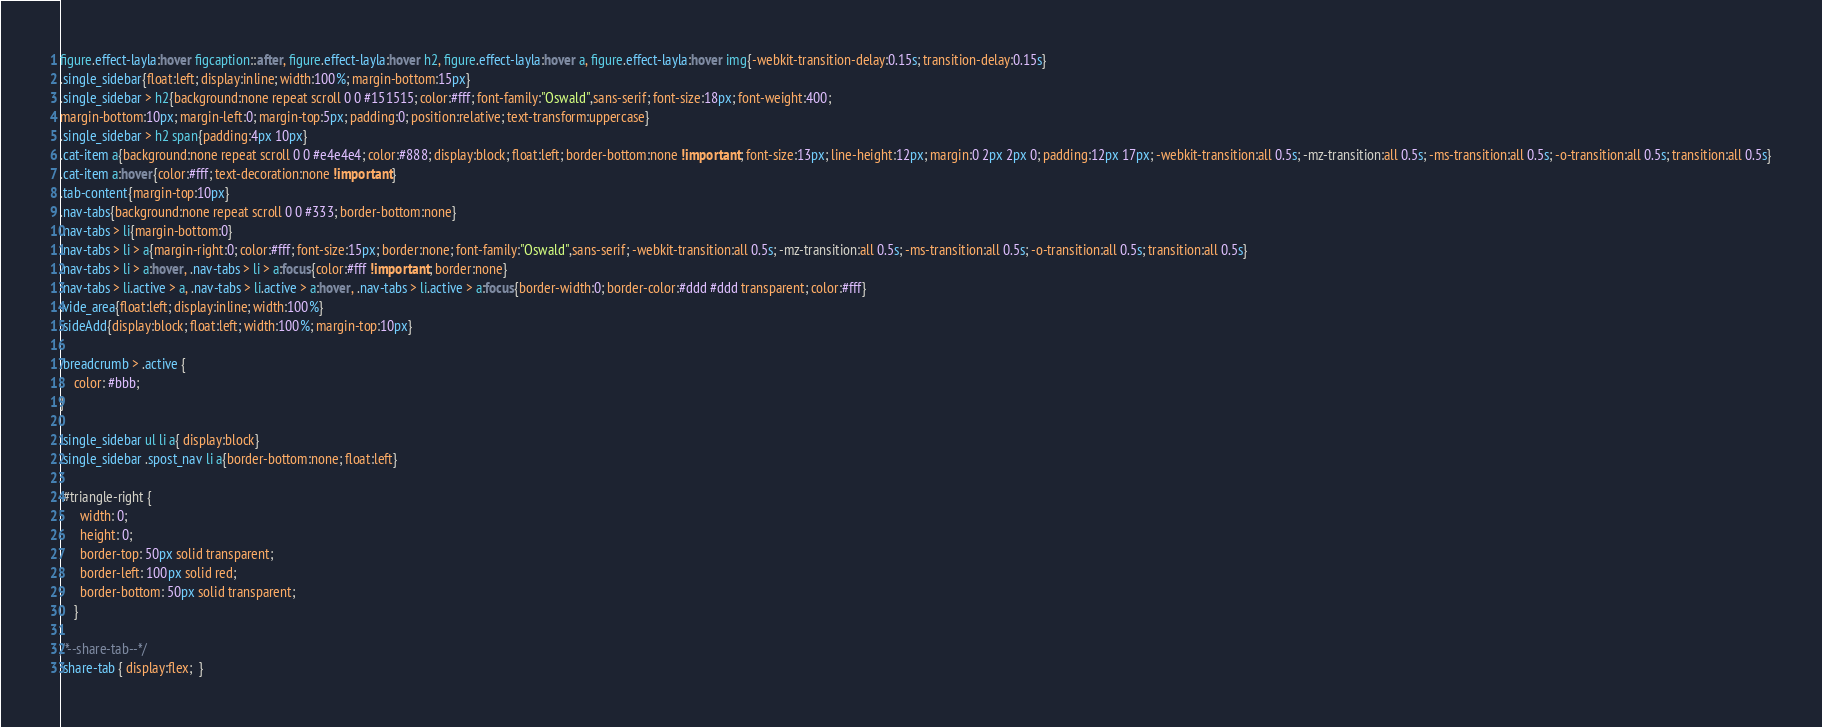Convert code to text. <code><loc_0><loc_0><loc_500><loc_500><_CSS_>figure.effect-layla:hover figcaption::after, figure.effect-layla:hover h2, figure.effect-layla:hover a, figure.effect-layla:hover img{-webkit-transition-delay:0.15s; transition-delay:0.15s}
.single_sidebar{float:left; display:inline; width:100%; margin-bottom:15px}
.single_sidebar > h2{background:none repeat scroll 0 0 #151515; color:#fff; font-family:"Oswald",sans-serif; font-size:18px; font-weight:400; 
margin-bottom:10px; margin-left:0; margin-top:5px; padding:0; position:relative; text-transform:uppercase}
.single_sidebar > h2 span{padding:4px 10px}
.cat-item a{background:none repeat scroll 0 0 #e4e4e4; color:#888; display:block; float:left; border-bottom:none !important; font-size:13px; line-height:12px; margin:0 2px 2px 0; padding:12px 17px; -webkit-transition:all 0.5s; -mz-transition:all 0.5s; -ms-transition:all 0.5s; -o-transition:all 0.5s; transition:all 0.5s}
.cat-item a:hover{color:#fff; text-decoration:none !important}
.tab-content{margin-top:10px}
.nav-tabs{background:none repeat scroll 0 0 #333; border-bottom:none}
.nav-tabs > li{margin-bottom:0}
.nav-tabs > li > a{margin-right:0; color:#fff; font-size:15px; border:none; font-family:"Oswald",sans-serif; -webkit-transition:all 0.5s; -mz-transition:all 0.5s; -ms-transition:all 0.5s; -o-transition:all 0.5s; transition:all 0.5s}
.nav-tabs > li > a:hover, .nav-tabs > li > a:focus{color:#fff !important; border:none}
.nav-tabs > li.active > a, .nav-tabs > li.active > a:hover, .nav-tabs > li.active > a:focus{border-width:0; border-color:#ddd #ddd transparent; color:#fff}
.vide_area{float:left; display:inline; width:100%}
.sideAdd{display:block; float:left; width:100%; margin-top:10px}

.breadcrumb > .active {
    color: #bbb;
}

.single_sidebar ul li a{ display:block}
.single_sidebar .spost_nav li a{border-bottom:none; float:left}

 #triangle-right {
      width: 0;
      height: 0;
      border-top: 50px solid transparent;
      border-left: 100px solid red;
      border-bottom: 50px solid transparent;
    }
	
/*--share-tab--*/
.share-tab { display:flex;  }</code> 